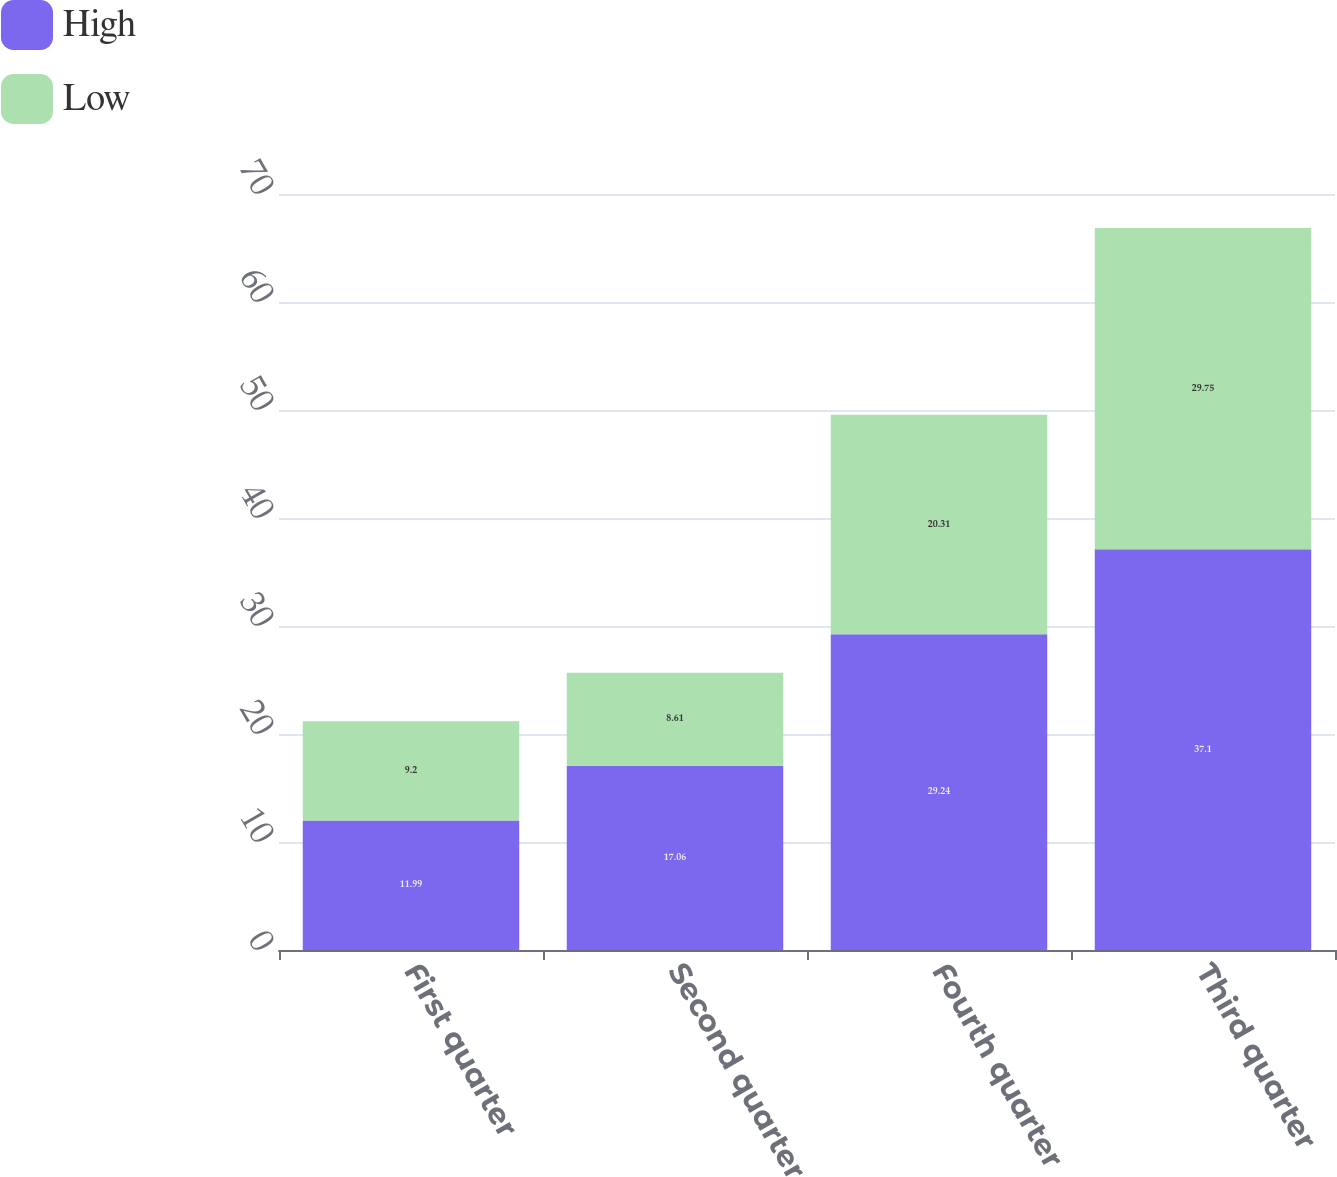<chart> <loc_0><loc_0><loc_500><loc_500><stacked_bar_chart><ecel><fcel>First quarter<fcel>Second quarter<fcel>Fourth quarter<fcel>Third quarter<nl><fcel>High<fcel>11.99<fcel>17.06<fcel>29.24<fcel>37.1<nl><fcel>Low<fcel>9.2<fcel>8.61<fcel>20.31<fcel>29.75<nl></chart> 